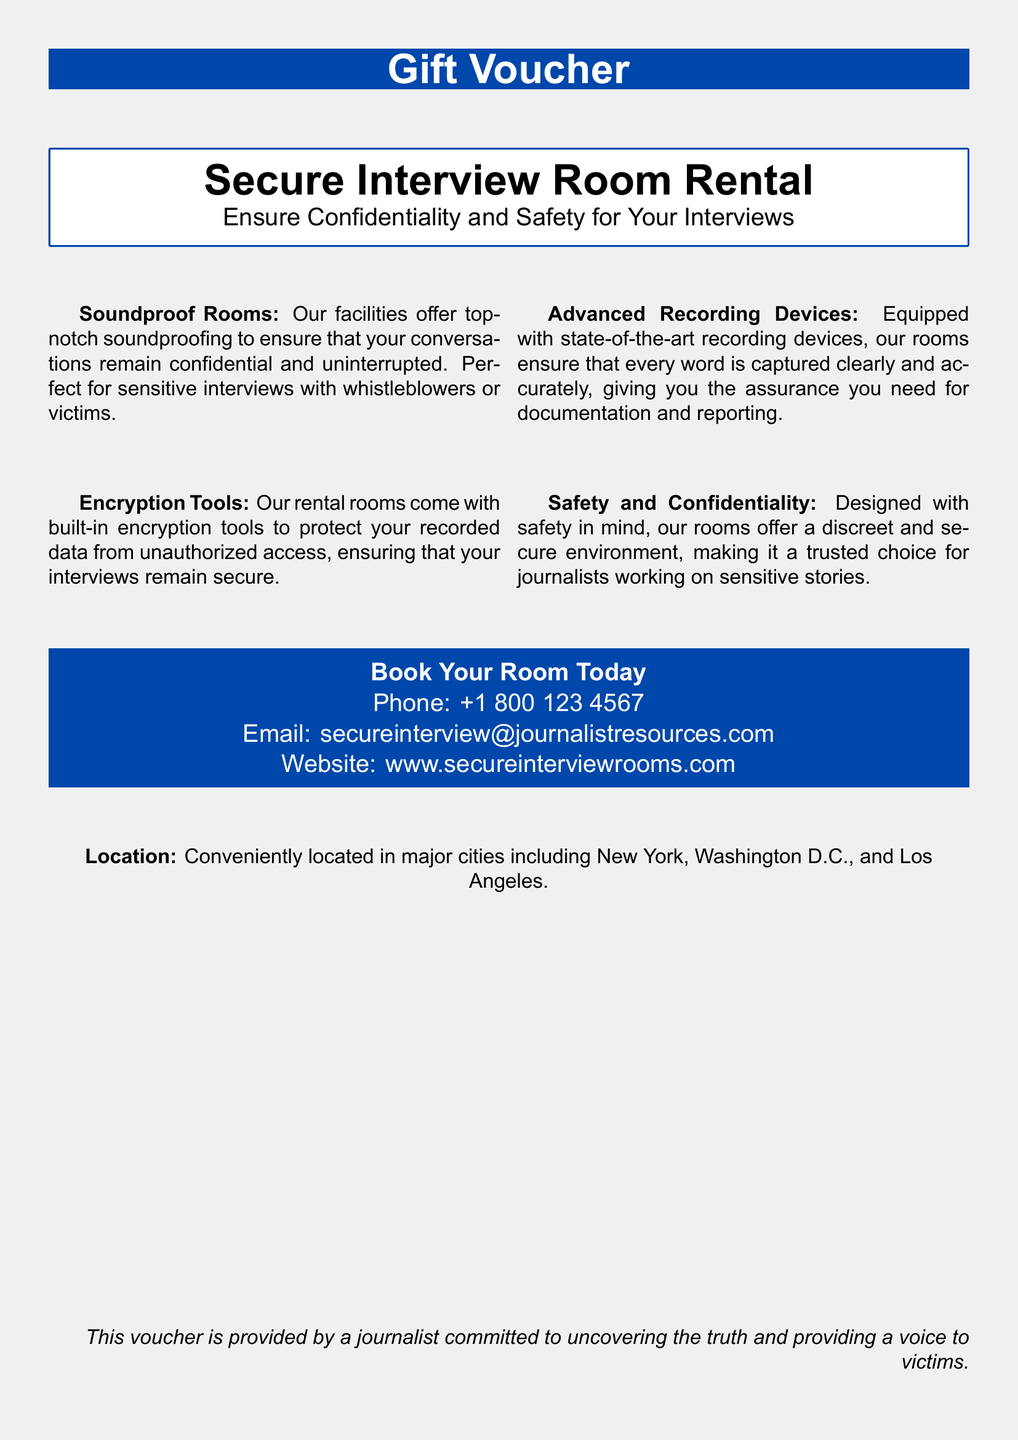What is the purpose of the Secure Interview Room Rental? The purpose is to ensure confidentiality and safety for interviews.
Answer: Ensure Confidentiality and Safety for Your Interviews What are the advanced features of the rental rooms? The features include soundproofing, advanced recording devices, and encryption tools.
Answer: Advanced recording devices What is the phone number provided in the document? The phone number to book the room is specified in the contact section.
Answer: +1 800 123 4567 Where are the secure interview rooms located? The locations are mentioned in the last section of the document.
Answer: New York, Washington D.C., Los Angeles What is the primary audience for this rental service? The document suggests that the service is tailored for journalists.
Answer: Journalists What addition is made to the security of interviews? The document states that built-in encryption tools are included for security.
Answer: Encryption tools What is guaranteed by the soundproofing of the rooms? The soundproofing guarantees that conversations remain confidential and uninterrupted.
Answer: Confidential and uninterrupted What is the email address provided for inquiries? An email address is listed for booking and questions regarding the rooms.
Answer: secureinterview@journalistresources.com What type of document is this? The document serves as a promotional offer with a structured layout.
Answer: Gift Voucher 